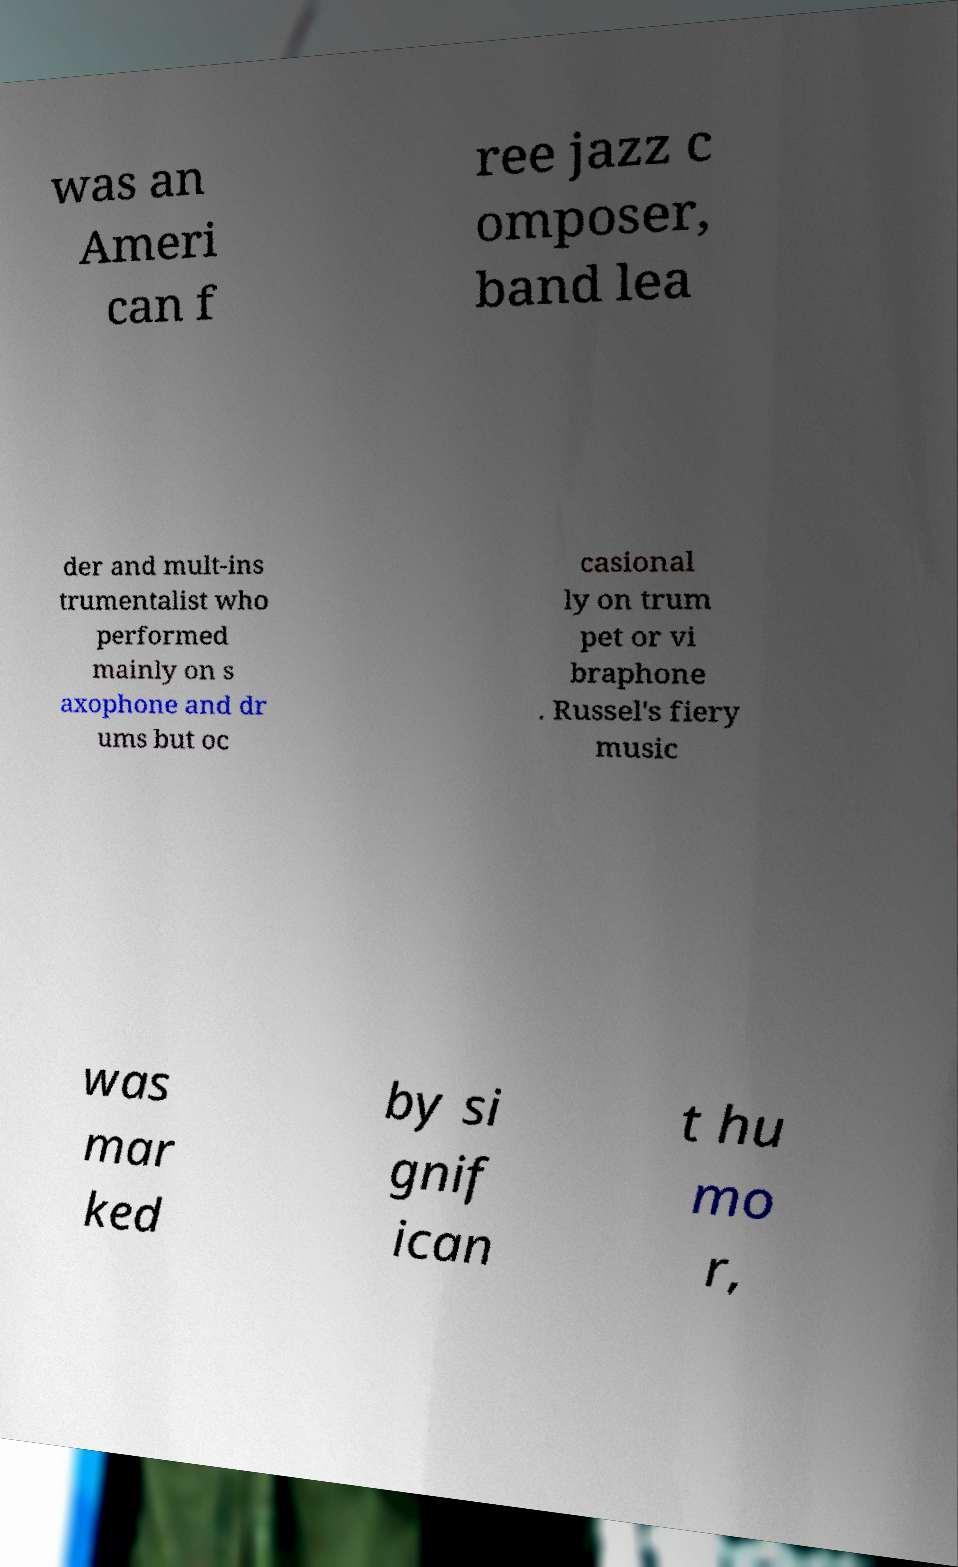For documentation purposes, I need the text within this image transcribed. Could you provide that? was an Ameri can f ree jazz c omposer, band lea der and mult-ins trumentalist who performed mainly on s axophone and dr ums but oc casional ly on trum pet or vi braphone . Russel's fiery music was mar ked by si gnif ican t hu mo r, 